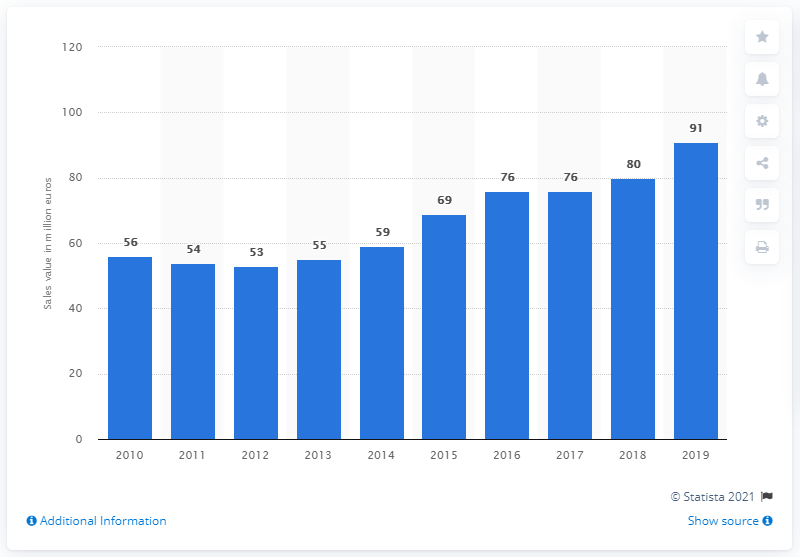Outline some significant characteristics in this image. The value of Antinori's wine sales in Italy in 2019 was approximately 91 million euros. 